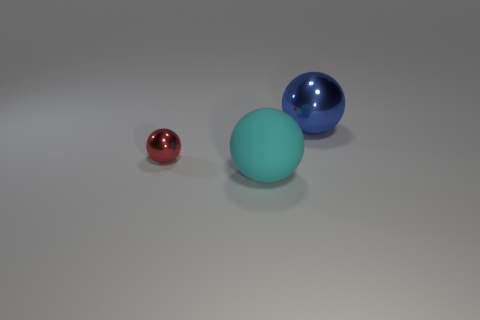Subtract all tiny red balls. How many balls are left? 2 Add 1 big blue things. How many objects exist? 4 Subtract all cyan balls. How many balls are left? 2 Subtract 2 spheres. How many spheres are left? 1 Subtract all purple spheres. Subtract all blue cylinders. How many spheres are left? 3 Subtract all green cylinders. How many brown spheres are left? 0 Subtract all brown matte cubes. Subtract all tiny red shiny spheres. How many objects are left? 2 Add 3 big cyan spheres. How many big cyan spheres are left? 4 Add 3 cyan things. How many cyan things exist? 4 Subtract 0 gray balls. How many objects are left? 3 